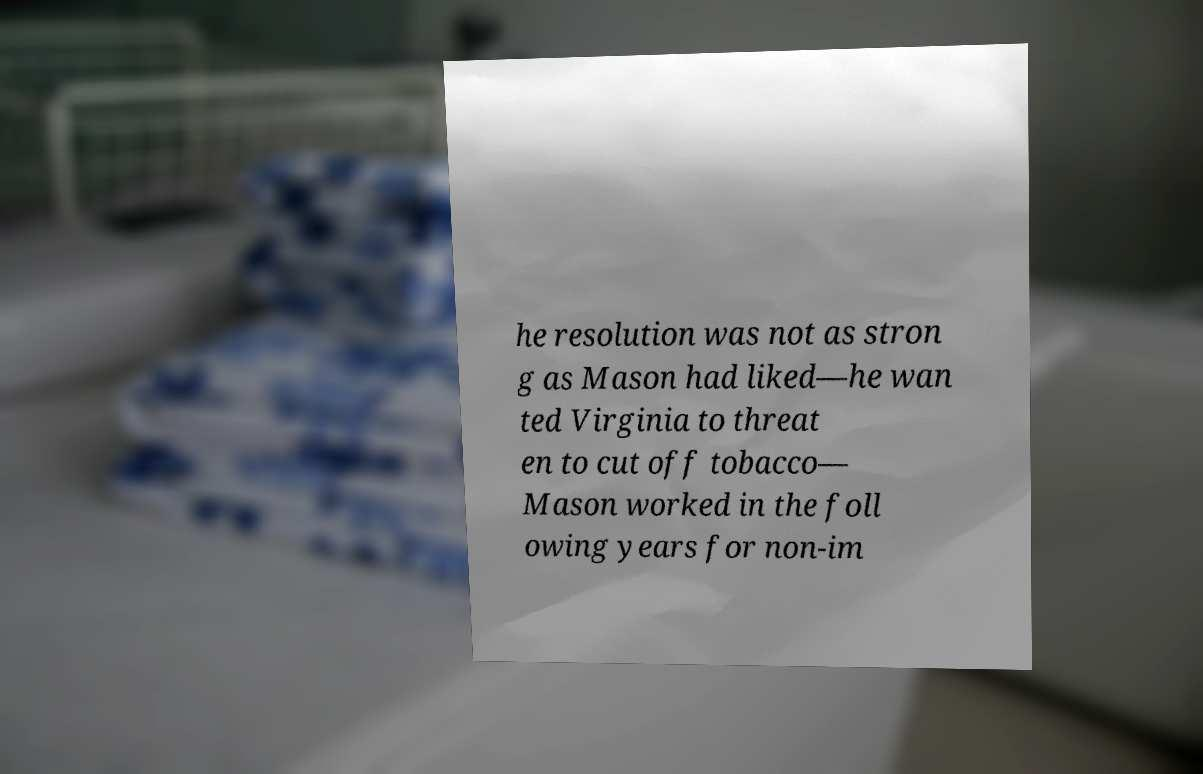I need the written content from this picture converted into text. Can you do that? he resolution was not as stron g as Mason had liked—he wan ted Virginia to threat en to cut off tobacco— Mason worked in the foll owing years for non-im 